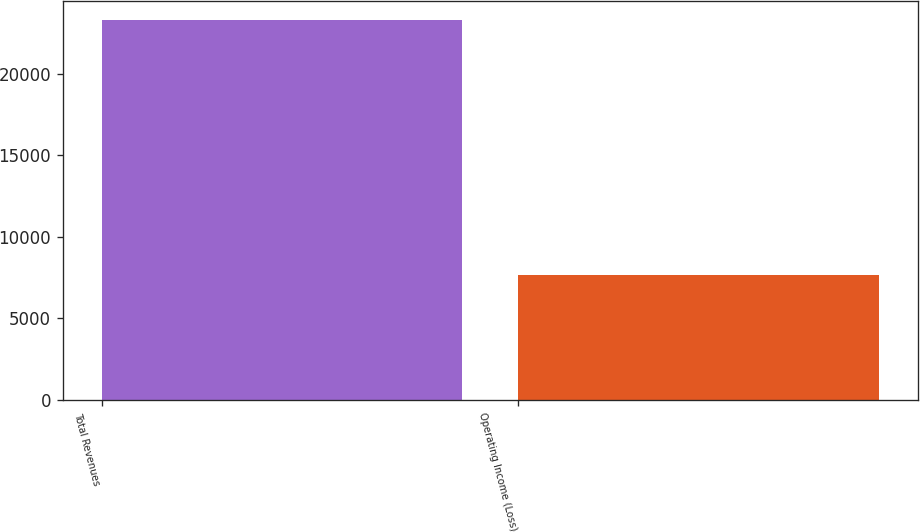Convert chart. <chart><loc_0><loc_0><loc_500><loc_500><bar_chart><fcel>Total Revenues<fcel>Operating Income (Loss)<nl><fcel>23309<fcel>7644<nl></chart> 